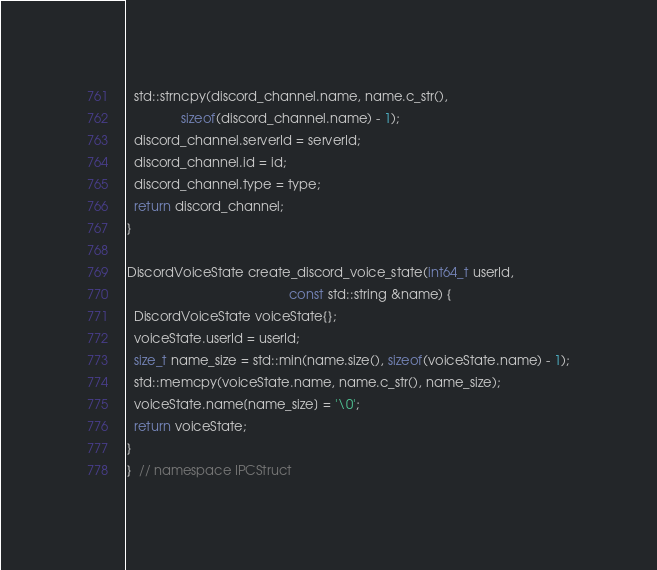<code> <loc_0><loc_0><loc_500><loc_500><_C++_>  std::strncpy(discord_channel.name, name.c_str(),
               sizeof(discord_channel.name) - 1);
  discord_channel.serverId = serverId;
  discord_channel.id = id;
  discord_channel.type = type;
  return discord_channel;
}

DiscordVoiceState create_discord_voice_state(int64_t userId,
                                             const std::string &name) {
  DiscordVoiceState voiceState{};
  voiceState.userId = userId;
  size_t name_size = std::min(name.size(), sizeof(voiceState.name) - 1);
  std::memcpy(voiceState.name, name.c_str(), name_size);
  voiceState.name[name_size] = '\0';
  return voiceState;
}
}  // namespace IPCStruct
</code> 